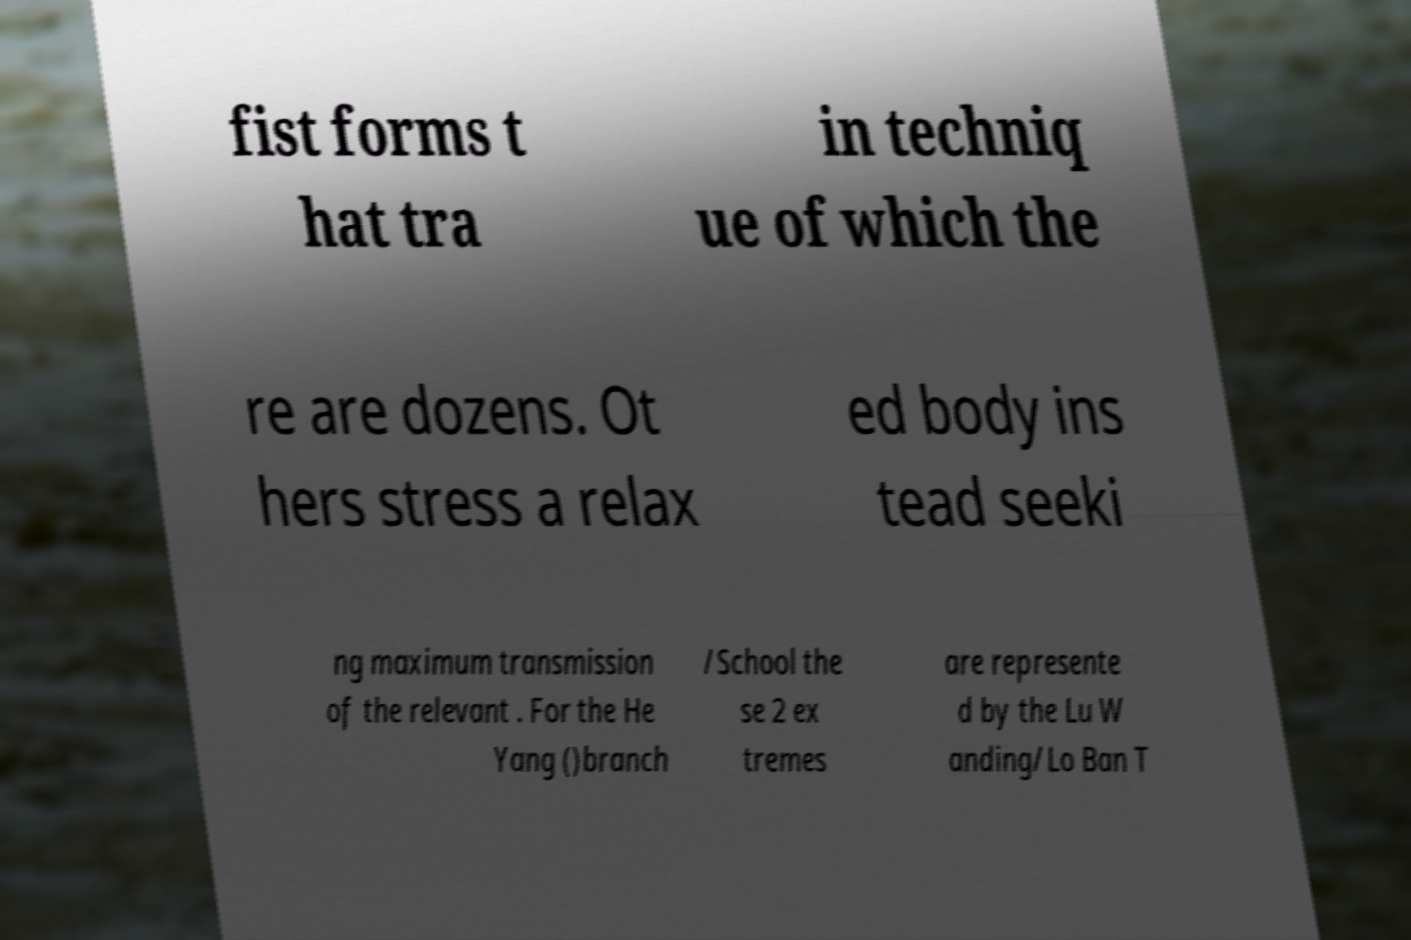There's text embedded in this image that I need extracted. Can you transcribe it verbatim? fist forms t hat tra in techniq ue of which the re are dozens. Ot hers stress a relax ed body ins tead seeki ng maximum transmission of the relevant . For the He Yang ()branch /School the se 2 ex tremes are represente d by the Lu W anding/Lo Ban T 